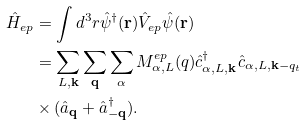<formula> <loc_0><loc_0><loc_500><loc_500>\hat { H } _ { e p } & = \int d ^ { 3 } r \hat { \psi } ^ { \dagger } ( { \mathbf r } ) \hat { V } _ { e p } \hat { \psi } ( { \mathbf r } ) \\ & = \sum _ { L , { \mathbf k } } \sum _ { \mathbf q } \sum _ { \alpha } M ^ { e p } _ { \alpha , L } ( q ) \hat { c } _ { \alpha , L , { \mathbf k } } ^ { \dagger } \hat { c } _ { \alpha , L , { \mathbf k - q _ { t } } } \\ & \times ( \hat { a } _ { \mathbf q } + \hat { a } _ { - { \mathbf q } } ^ { \dagger } ) .</formula> 